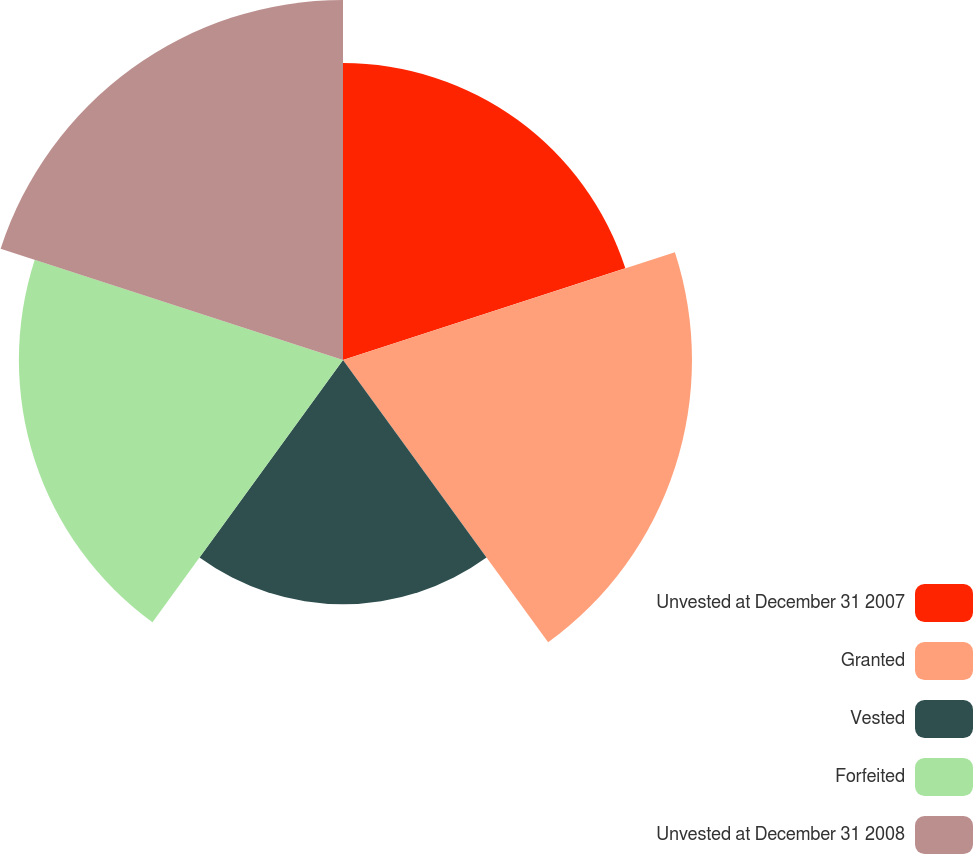Convert chart to OTSL. <chart><loc_0><loc_0><loc_500><loc_500><pie_chart><fcel>Unvested at December 31 2007<fcel>Granted<fcel>Vested<fcel>Forfeited<fcel>Unvested at December 31 2008<nl><fcel>18.86%<fcel>22.17%<fcel>15.51%<fcel>20.59%<fcel>22.87%<nl></chart> 